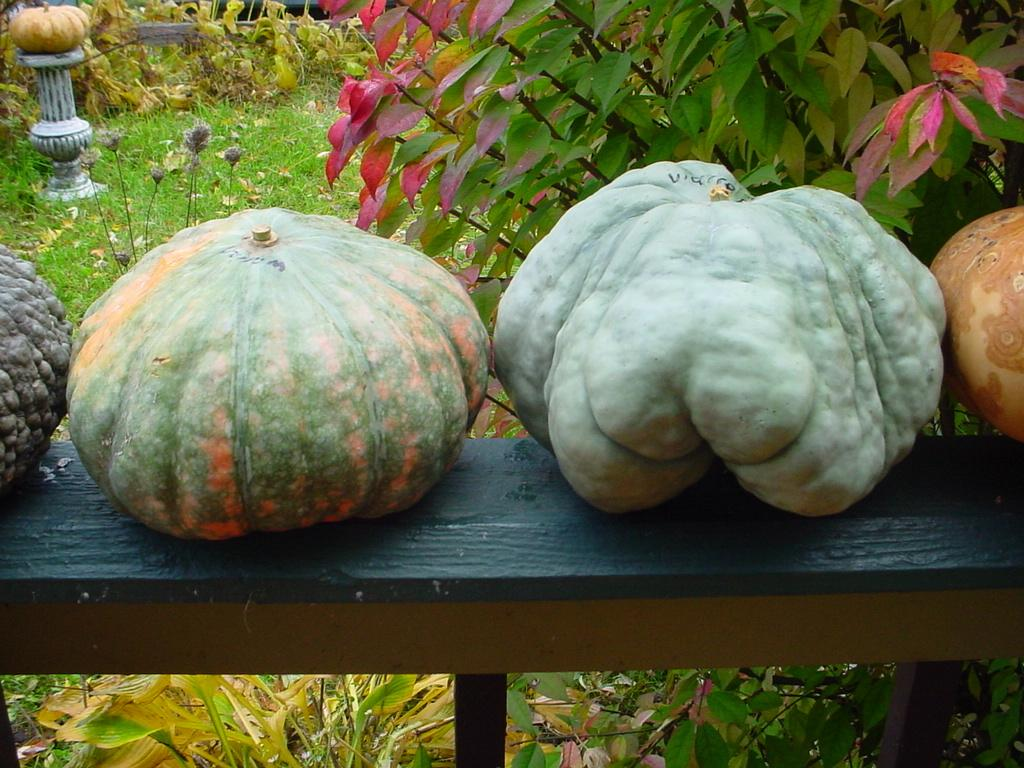What types of objects are in the image? There are different types of gourds in the image. Where are the gourds placed? The gourds are kept on a bench. What can be seen in the background of the image? There is grass visible in the image. Are there any plants in the image? Yes, there are plants in the image. What type of hair can be seen on the gourds in the image? There is no hair present on the gourds in the image. What title is given to the collection of gourds in the image? There is no title given to the collection of gourds in the image. 